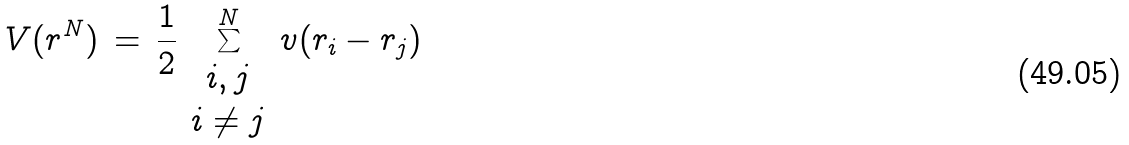Convert formula to latex. <formula><loc_0><loc_0><loc_500><loc_500>V ( r ^ { N } ) \, = \, { \frac { 1 } { 2 } } \sum _ { \begin{array} { c } i , j \\ i \ne j \end{array} } ^ { N } v ( r _ { i } - r _ { j } )</formula> 